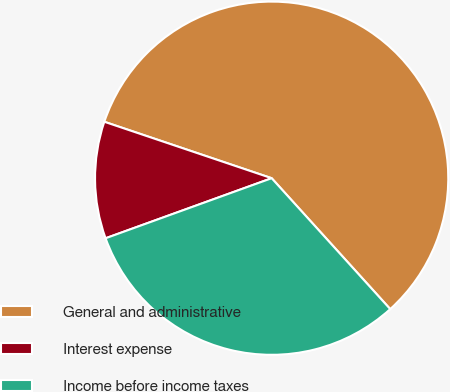Convert chart to OTSL. <chart><loc_0><loc_0><loc_500><loc_500><pie_chart><fcel>General and administrative<fcel>Interest expense<fcel>Income before income taxes<nl><fcel>58.11%<fcel>10.7%<fcel>31.19%<nl></chart> 